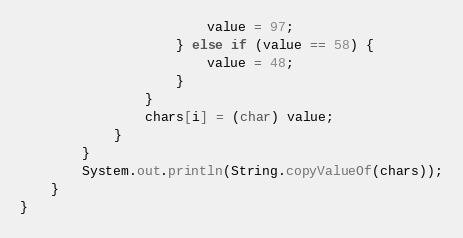Convert code to text. <code><loc_0><loc_0><loc_500><loc_500><_Java_>                        value = 97;
                    } else if (value == 58) {
                        value = 48;
                    }
                }
                chars[i] = (char) value;
            }
        }
        System.out.println(String.copyValueOf(chars));
    }
}
</code> 